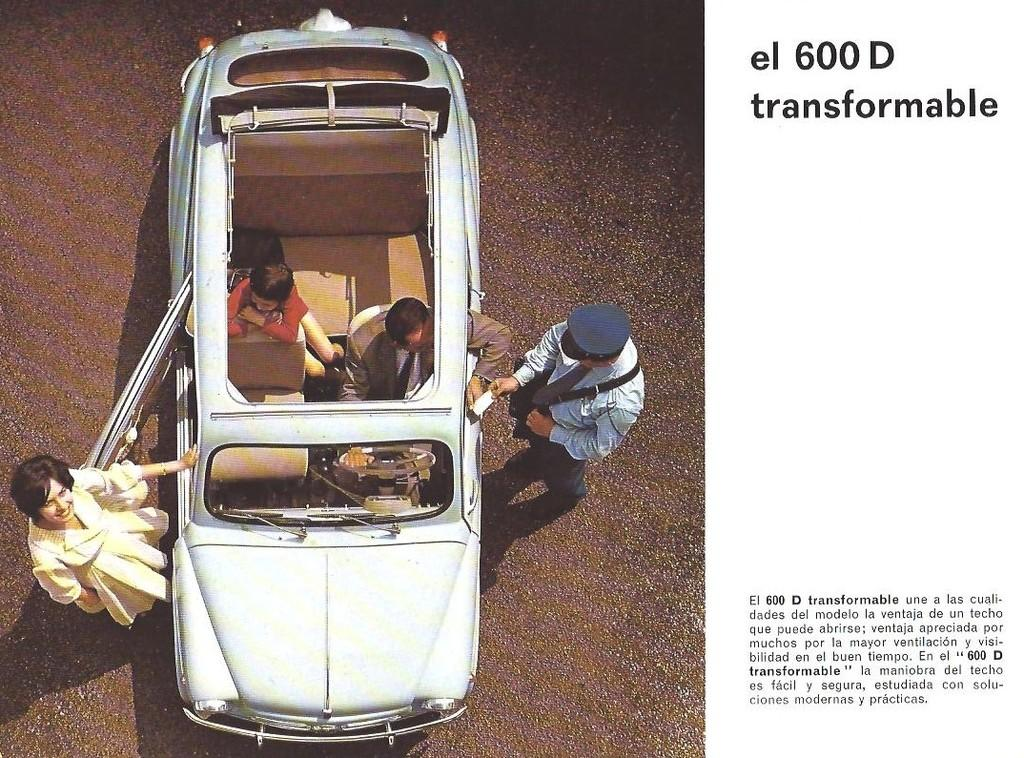What is the main subject of the image? The main subject of the image is a car. Where are the two persons in the image located? Two persons are standing on the left side of the image, and two persons are sitting in the car. What can be seen on the right side of the image? There is some text on the right side of the image. What type of suit is the car wearing in the image? Cars do not wear suits; the question is not applicable to the image. How does the car taste in the image? Cars do not have a taste; the question is not applicable to the image. 